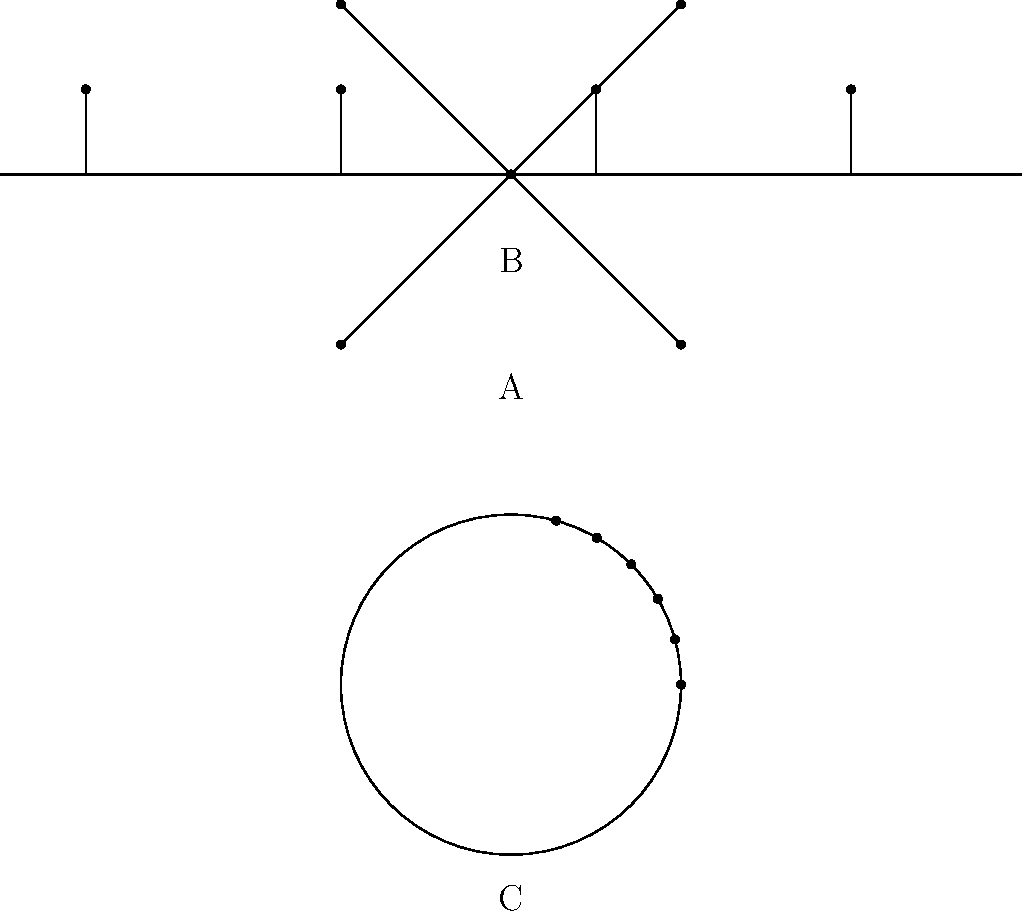Identify the network topologies represented by diagrams A, B, and C. Which topology is most suitable for a small computer lab in your university, considering factors like ease of installation and cost-effectiveness? Let's analyze each topology:

1. Diagram A: Star Topology
   - Central node connected to all other nodes
   - Easy to install and manage
   - Fault isolation is simple
   - Suitable for small to medium networks

2. Diagram B: Bus Topology
   - All nodes connected to a single cable (bus)
   - Easy to install and requires less cable
   - Performance degrades as more devices are added
   - Failure in the main cable affects the entire network

3. Diagram C: Ring Topology
   - Nodes connected in a circular fashion
   - Data travels in one direction
   - Difficult to add or remove devices
   - Failure of one node can affect the entire network

For a small computer lab in a university setting, the Star topology (A) is most suitable because:

1. Easy installation and management: The central node (switch or hub) simplifies network administration.
2. Scalability: New devices can be easily added without disrupting the entire network.
3. Fault tolerance: If one connection fails, it doesn't affect other devices.
4. Cost-effective for small networks: While it may require more cable than a bus topology, the benefits outweigh the slightly higher cost for a small lab.
5. Familiar to most IT staff: Star topology is widely used, making it easier to find support and expertise.

Given your background as a freshman student, the star topology would be the most straightforward to understand and work with in your university computer lab.
Answer: Star topology (A) 